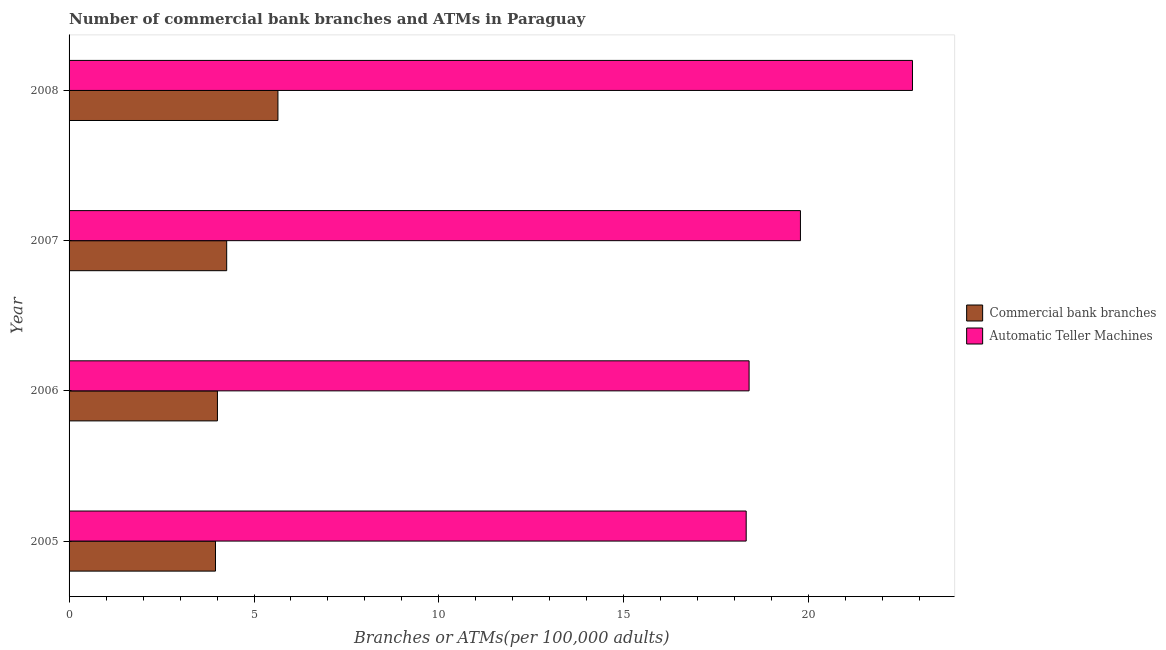How many different coloured bars are there?
Give a very brief answer. 2. How many groups of bars are there?
Give a very brief answer. 4. Are the number of bars per tick equal to the number of legend labels?
Give a very brief answer. Yes. How many bars are there on the 1st tick from the bottom?
Provide a succinct answer. 2. What is the label of the 3rd group of bars from the top?
Offer a terse response. 2006. What is the number of commercal bank branches in 2008?
Provide a short and direct response. 5.65. Across all years, what is the maximum number of atms?
Your answer should be very brief. 22.8. Across all years, what is the minimum number of commercal bank branches?
Give a very brief answer. 3.96. In which year was the number of commercal bank branches minimum?
Provide a succinct answer. 2005. What is the total number of commercal bank branches in the graph?
Your answer should be very brief. 17.88. What is the difference between the number of commercal bank branches in 2005 and that in 2008?
Ensure brevity in your answer.  -1.69. What is the difference between the number of commercal bank branches in 2005 and the number of atms in 2008?
Your answer should be compact. -18.85. What is the average number of commercal bank branches per year?
Your response must be concise. 4.47. In the year 2007, what is the difference between the number of atms and number of commercal bank branches?
Offer a terse response. 15.51. What is the ratio of the number of atms in 2007 to that in 2008?
Keep it short and to the point. 0.87. Is the difference between the number of commercal bank branches in 2006 and 2008 greater than the difference between the number of atms in 2006 and 2008?
Provide a succinct answer. Yes. What is the difference between the highest and the second highest number of atms?
Your answer should be compact. 3.03. What is the difference between the highest and the lowest number of commercal bank branches?
Offer a terse response. 1.69. In how many years, is the number of atms greater than the average number of atms taken over all years?
Provide a short and direct response. 1. What does the 1st bar from the top in 2008 represents?
Your answer should be very brief. Automatic Teller Machines. What does the 1st bar from the bottom in 2007 represents?
Offer a terse response. Commercial bank branches. Are all the bars in the graph horizontal?
Your answer should be very brief. Yes. How many years are there in the graph?
Provide a succinct answer. 4. Where does the legend appear in the graph?
Provide a succinct answer. Center right. How are the legend labels stacked?
Give a very brief answer. Vertical. What is the title of the graph?
Make the answer very short. Number of commercial bank branches and ATMs in Paraguay. What is the label or title of the X-axis?
Your answer should be very brief. Branches or ATMs(per 100,0 adults). What is the Branches or ATMs(per 100,000 adults) in Commercial bank branches in 2005?
Your answer should be very brief. 3.96. What is the Branches or ATMs(per 100,000 adults) of Automatic Teller Machines in 2005?
Offer a very short reply. 18.31. What is the Branches or ATMs(per 100,000 adults) in Commercial bank branches in 2006?
Make the answer very short. 4.01. What is the Branches or ATMs(per 100,000 adults) in Automatic Teller Machines in 2006?
Your answer should be compact. 18.39. What is the Branches or ATMs(per 100,000 adults) of Commercial bank branches in 2007?
Your response must be concise. 4.26. What is the Branches or ATMs(per 100,000 adults) of Automatic Teller Machines in 2007?
Provide a succinct answer. 19.78. What is the Branches or ATMs(per 100,000 adults) in Commercial bank branches in 2008?
Your answer should be compact. 5.65. What is the Branches or ATMs(per 100,000 adults) in Automatic Teller Machines in 2008?
Ensure brevity in your answer.  22.8. Across all years, what is the maximum Branches or ATMs(per 100,000 adults) of Commercial bank branches?
Ensure brevity in your answer.  5.65. Across all years, what is the maximum Branches or ATMs(per 100,000 adults) of Automatic Teller Machines?
Provide a succinct answer. 22.8. Across all years, what is the minimum Branches or ATMs(per 100,000 adults) of Commercial bank branches?
Make the answer very short. 3.96. Across all years, what is the minimum Branches or ATMs(per 100,000 adults) of Automatic Teller Machines?
Make the answer very short. 18.31. What is the total Branches or ATMs(per 100,000 adults) in Commercial bank branches in the graph?
Make the answer very short. 17.88. What is the total Branches or ATMs(per 100,000 adults) in Automatic Teller Machines in the graph?
Offer a terse response. 79.27. What is the difference between the Branches or ATMs(per 100,000 adults) of Commercial bank branches in 2005 and that in 2006?
Offer a very short reply. -0.05. What is the difference between the Branches or ATMs(per 100,000 adults) in Automatic Teller Machines in 2005 and that in 2006?
Offer a very short reply. -0.08. What is the difference between the Branches or ATMs(per 100,000 adults) of Commercial bank branches in 2005 and that in 2007?
Your response must be concise. -0.3. What is the difference between the Branches or ATMs(per 100,000 adults) of Automatic Teller Machines in 2005 and that in 2007?
Ensure brevity in your answer.  -1.47. What is the difference between the Branches or ATMs(per 100,000 adults) in Commercial bank branches in 2005 and that in 2008?
Provide a short and direct response. -1.69. What is the difference between the Branches or ATMs(per 100,000 adults) of Automatic Teller Machines in 2005 and that in 2008?
Ensure brevity in your answer.  -4.5. What is the difference between the Branches or ATMs(per 100,000 adults) of Commercial bank branches in 2006 and that in 2007?
Offer a terse response. -0.25. What is the difference between the Branches or ATMs(per 100,000 adults) of Automatic Teller Machines in 2006 and that in 2007?
Offer a very short reply. -1.39. What is the difference between the Branches or ATMs(per 100,000 adults) in Commercial bank branches in 2006 and that in 2008?
Your answer should be very brief. -1.64. What is the difference between the Branches or ATMs(per 100,000 adults) of Automatic Teller Machines in 2006 and that in 2008?
Provide a short and direct response. -4.42. What is the difference between the Branches or ATMs(per 100,000 adults) of Commercial bank branches in 2007 and that in 2008?
Your answer should be compact. -1.39. What is the difference between the Branches or ATMs(per 100,000 adults) of Automatic Teller Machines in 2007 and that in 2008?
Give a very brief answer. -3.03. What is the difference between the Branches or ATMs(per 100,000 adults) in Commercial bank branches in 2005 and the Branches or ATMs(per 100,000 adults) in Automatic Teller Machines in 2006?
Give a very brief answer. -14.43. What is the difference between the Branches or ATMs(per 100,000 adults) of Commercial bank branches in 2005 and the Branches or ATMs(per 100,000 adults) of Automatic Teller Machines in 2007?
Give a very brief answer. -15.82. What is the difference between the Branches or ATMs(per 100,000 adults) in Commercial bank branches in 2005 and the Branches or ATMs(per 100,000 adults) in Automatic Teller Machines in 2008?
Give a very brief answer. -18.85. What is the difference between the Branches or ATMs(per 100,000 adults) in Commercial bank branches in 2006 and the Branches or ATMs(per 100,000 adults) in Automatic Teller Machines in 2007?
Make the answer very short. -15.76. What is the difference between the Branches or ATMs(per 100,000 adults) in Commercial bank branches in 2006 and the Branches or ATMs(per 100,000 adults) in Automatic Teller Machines in 2008?
Provide a short and direct response. -18.79. What is the difference between the Branches or ATMs(per 100,000 adults) in Commercial bank branches in 2007 and the Branches or ATMs(per 100,000 adults) in Automatic Teller Machines in 2008?
Offer a terse response. -18.54. What is the average Branches or ATMs(per 100,000 adults) of Commercial bank branches per year?
Your answer should be very brief. 4.47. What is the average Branches or ATMs(per 100,000 adults) in Automatic Teller Machines per year?
Give a very brief answer. 19.82. In the year 2005, what is the difference between the Branches or ATMs(per 100,000 adults) in Commercial bank branches and Branches or ATMs(per 100,000 adults) in Automatic Teller Machines?
Make the answer very short. -14.35. In the year 2006, what is the difference between the Branches or ATMs(per 100,000 adults) of Commercial bank branches and Branches or ATMs(per 100,000 adults) of Automatic Teller Machines?
Offer a very short reply. -14.38. In the year 2007, what is the difference between the Branches or ATMs(per 100,000 adults) in Commercial bank branches and Branches or ATMs(per 100,000 adults) in Automatic Teller Machines?
Offer a terse response. -15.51. In the year 2008, what is the difference between the Branches or ATMs(per 100,000 adults) of Commercial bank branches and Branches or ATMs(per 100,000 adults) of Automatic Teller Machines?
Your answer should be very brief. -17.16. What is the ratio of the Branches or ATMs(per 100,000 adults) of Commercial bank branches in 2005 to that in 2007?
Provide a succinct answer. 0.93. What is the ratio of the Branches or ATMs(per 100,000 adults) in Automatic Teller Machines in 2005 to that in 2007?
Ensure brevity in your answer.  0.93. What is the ratio of the Branches or ATMs(per 100,000 adults) in Commercial bank branches in 2005 to that in 2008?
Give a very brief answer. 0.7. What is the ratio of the Branches or ATMs(per 100,000 adults) of Automatic Teller Machines in 2005 to that in 2008?
Keep it short and to the point. 0.8. What is the ratio of the Branches or ATMs(per 100,000 adults) in Commercial bank branches in 2006 to that in 2007?
Provide a succinct answer. 0.94. What is the ratio of the Branches or ATMs(per 100,000 adults) in Automatic Teller Machines in 2006 to that in 2007?
Offer a terse response. 0.93. What is the ratio of the Branches or ATMs(per 100,000 adults) of Commercial bank branches in 2006 to that in 2008?
Ensure brevity in your answer.  0.71. What is the ratio of the Branches or ATMs(per 100,000 adults) of Automatic Teller Machines in 2006 to that in 2008?
Provide a short and direct response. 0.81. What is the ratio of the Branches or ATMs(per 100,000 adults) of Commercial bank branches in 2007 to that in 2008?
Your answer should be very brief. 0.75. What is the ratio of the Branches or ATMs(per 100,000 adults) in Automatic Teller Machines in 2007 to that in 2008?
Make the answer very short. 0.87. What is the difference between the highest and the second highest Branches or ATMs(per 100,000 adults) in Commercial bank branches?
Make the answer very short. 1.39. What is the difference between the highest and the second highest Branches or ATMs(per 100,000 adults) in Automatic Teller Machines?
Make the answer very short. 3.03. What is the difference between the highest and the lowest Branches or ATMs(per 100,000 adults) in Commercial bank branches?
Your response must be concise. 1.69. What is the difference between the highest and the lowest Branches or ATMs(per 100,000 adults) of Automatic Teller Machines?
Keep it short and to the point. 4.5. 